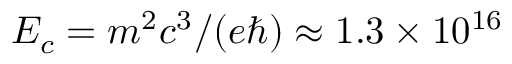Convert formula to latex. <formula><loc_0><loc_0><loc_500><loc_500>E _ { c } = m ^ { 2 } c ^ { 3 } / ( e \hbar { ) } \approx 1 . 3 \times 1 0 ^ { 1 6 }</formula> 